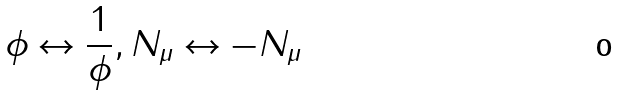Convert formula to latex. <formula><loc_0><loc_0><loc_500><loc_500>\phi \leftrightarrow \frac { 1 } { \phi } , N _ { \mu } \leftrightarrow - N _ { \mu }</formula> 